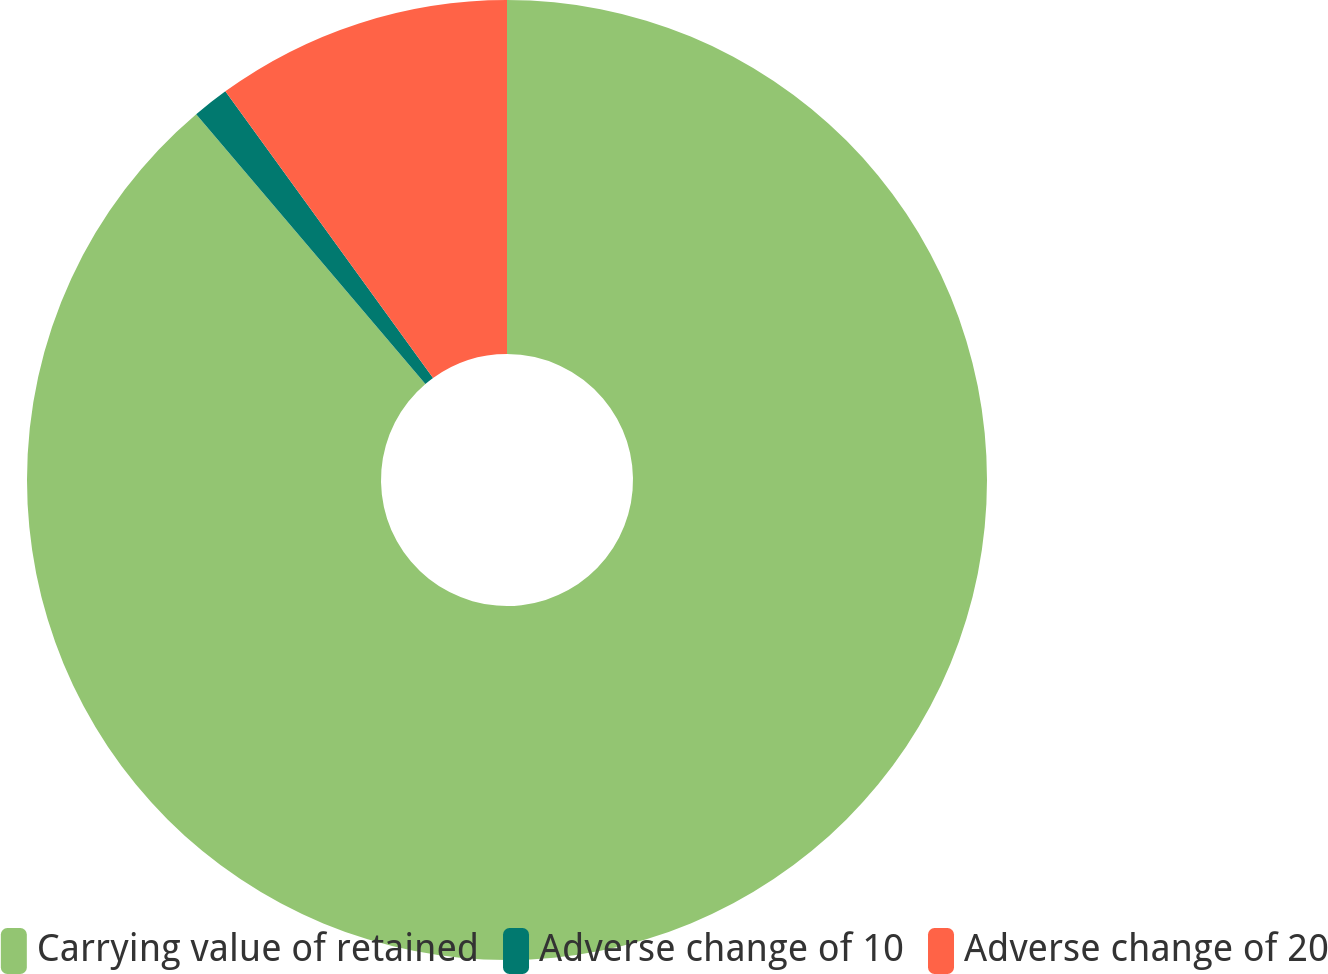<chart> <loc_0><loc_0><loc_500><loc_500><pie_chart><fcel>Carrying value of retained<fcel>Adverse change of 10<fcel>Adverse change of 20<nl><fcel>88.79%<fcel>1.23%<fcel>9.98%<nl></chart> 